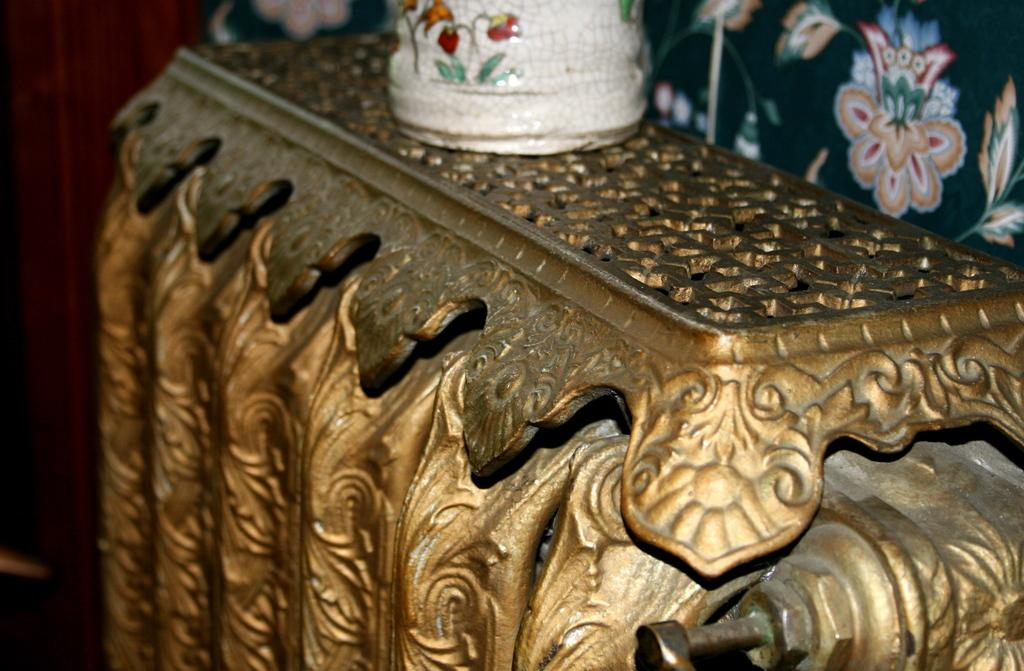What types of objects can be seen in the image? There are designed objects in the image. Can you see a duck swimming in the image? There is no duck present in the image. What is the cause of the designed objects in the image? The provided facts do not mention the cause or reason for the designed objects being in the image. 